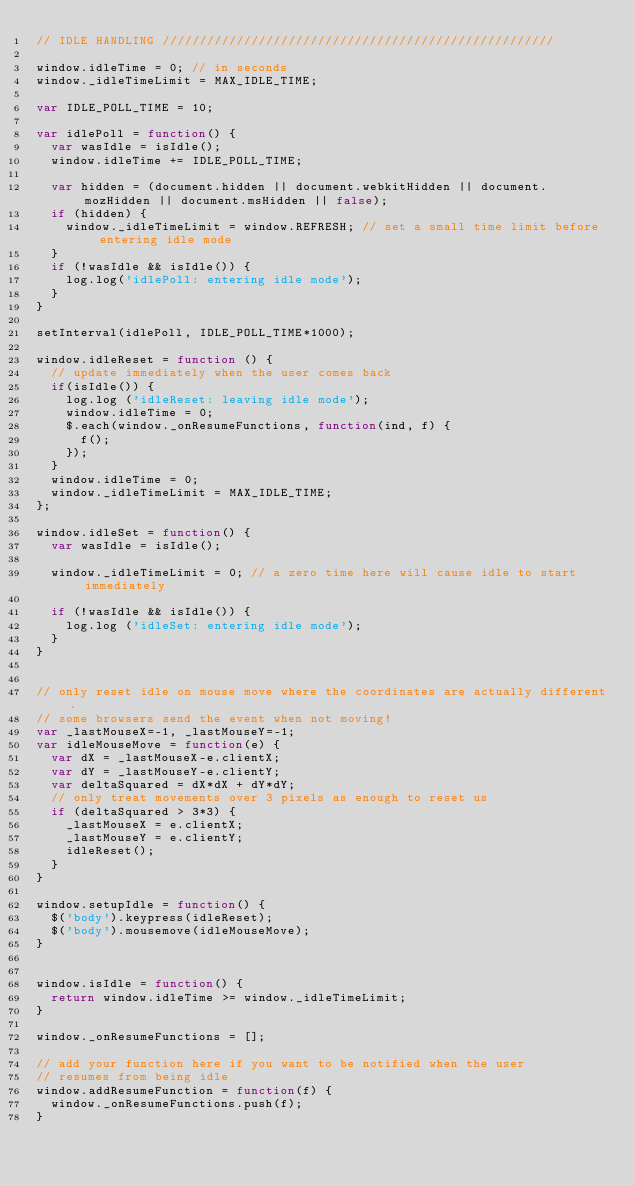<code> <loc_0><loc_0><loc_500><loc_500><_JavaScript_>// IDLE HANDLING /////////////////////////////////////////////////////

window.idleTime = 0; // in seconds
window._idleTimeLimit = MAX_IDLE_TIME;

var IDLE_POLL_TIME = 10;

var idlePoll = function() {
  var wasIdle = isIdle();
  window.idleTime += IDLE_POLL_TIME;

  var hidden = (document.hidden || document.webkitHidden || document.mozHidden || document.msHidden || false);
  if (hidden) {
    window._idleTimeLimit = window.REFRESH; // set a small time limit before entering idle mode
  }
  if (!wasIdle && isIdle()) {
    log.log('idlePoll: entering idle mode');
  }
}

setInterval(idlePoll, IDLE_POLL_TIME*1000);

window.idleReset = function () {
  // update immediately when the user comes back
  if(isIdle()) {
    log.log ('idleReset: leaving idle mode');
    window.idleTime = 0;
    $.each(window._onResumeFunctions, function(ind, f) {
      f();
    });
  }
  window.idleTime = 0;
  window._idleTimeLimit = MAX_IDLE_TIME;
};

window.idleSet = function() {
  var wasIdle = isIdle();

  window._idleTimeLimit = 0; // a zero time here will cause idle to start immediately

  if (!wasIdle && isIdle()) {
    log.log ('idleSet: entering idle mode');
  }
}


// only reset idle on mouse move where the coordinates are actually different.
// some browsers send the event when not moving!
var _lastMouseX=-1, _lastMouseY=-1;
var idleMouseMove = function(e) {
  var dX = _lastMouseX-e.clientX;
  var dY = _lastMouseY-e.clientY;
  var deltaSquared = dX*dX + dY*dY;
  // only treat movements over 3 pixels as enough to reset us
  if (deltaSquared > 3*3) {
    _lastMouseX = e.clientX;
    _lastMouseY = e.clientY;
    idleReset();
  }
}

window.setupIdle = function() {
  $('body').keypress(idleReset);
  $('body').mousemove(idleMouseMove);
}


window.isIdle = function() {
  return window.idleTime >= window._idleTimeLimit;
}

window._onResumeFunctions = [];

// add your function here if you want to be notified when the user
// resumes from being idle
window.addResumeFunction = function(f) {
  window._onResumeFunctions.push(f);
}
</code> 